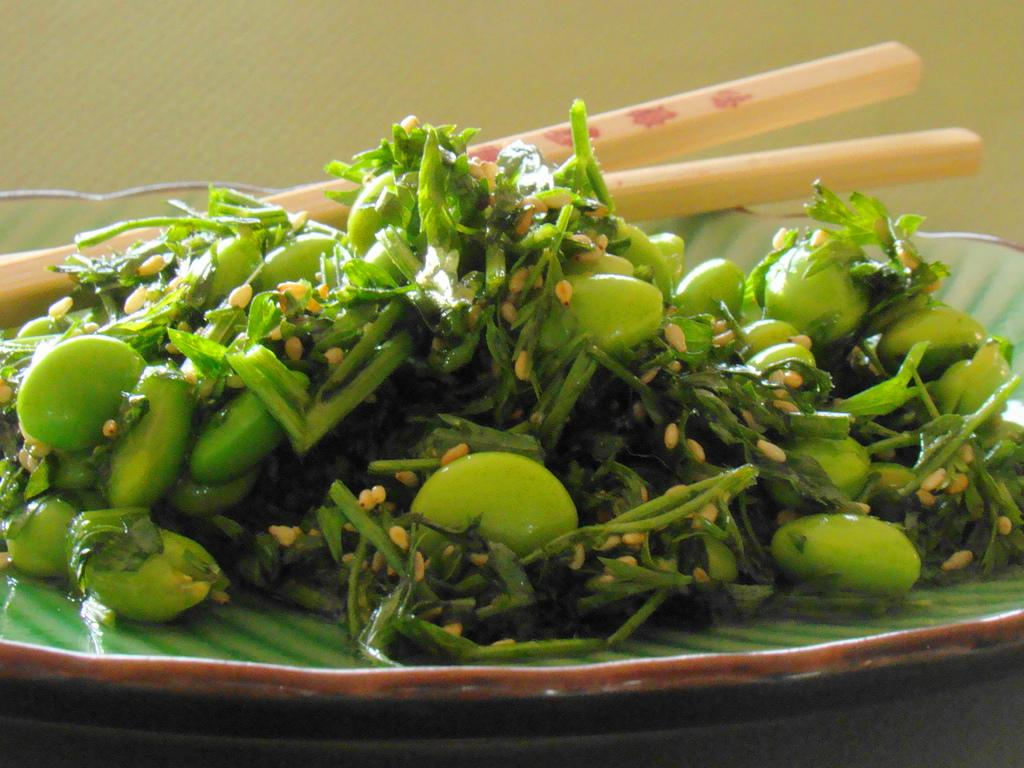What is on the plate that is visible in the image? The plate has leafy vegetables on it. Are there any utensils on the plate? Yes, there are chopsticks on the plate. What else can be seen on the plate besides the vegetables and chopsticks? There is food on the plate. Where is the plate located in the image? The plate is placed on a table. What is the name of the goat in the image? There is no goat present in the image. What type of yoke is used to hold the vegetables on the plate? There is no yoke present in the image; the vegetables are simply placed on the plate. 